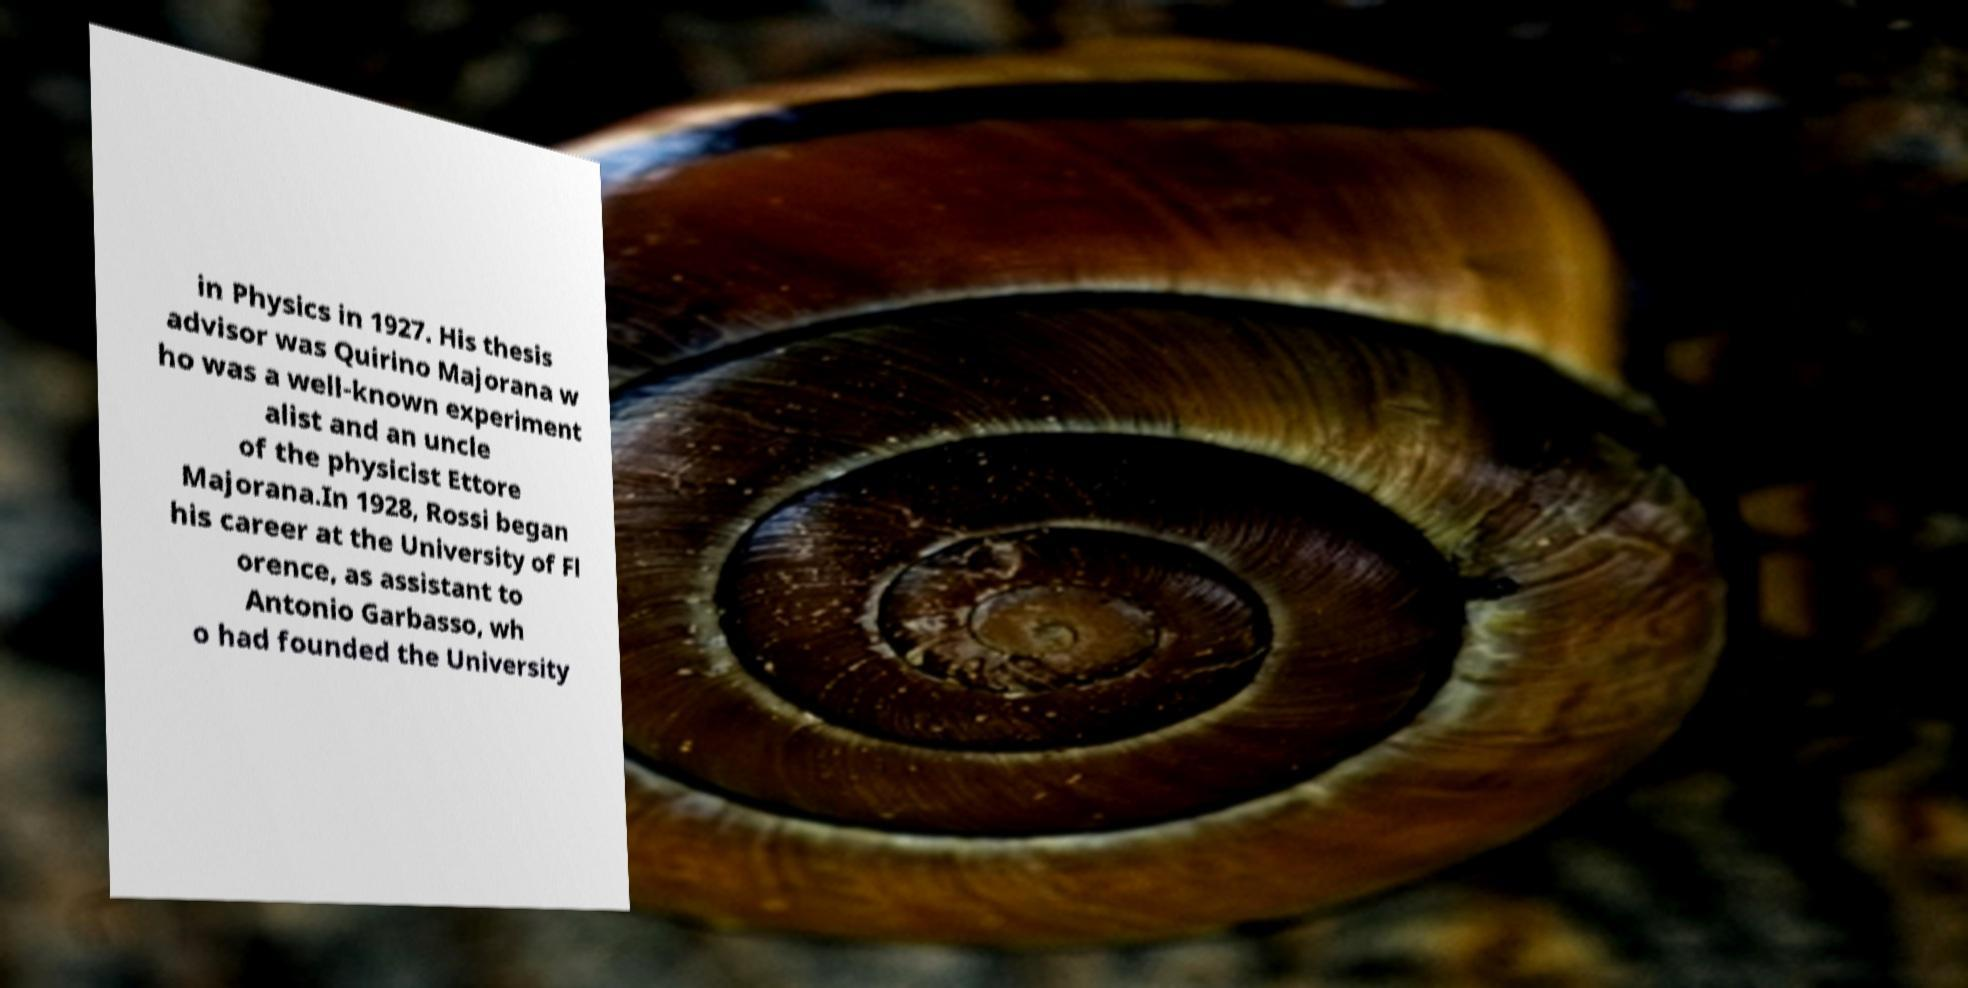Can you read and provide the text displayed in the image?This photo seems to have some interesting text. Can you extract and type it out for me? in Physics in 1927. His thesis advisor was Quirino Majorana w ho was a well-known experiment alist and an uncle of the physicist Ettore Majorana.In 1928, Rossi began his career at the University of Fl orence, as assistant to Antonio Garbasso, wh o had founded the University 